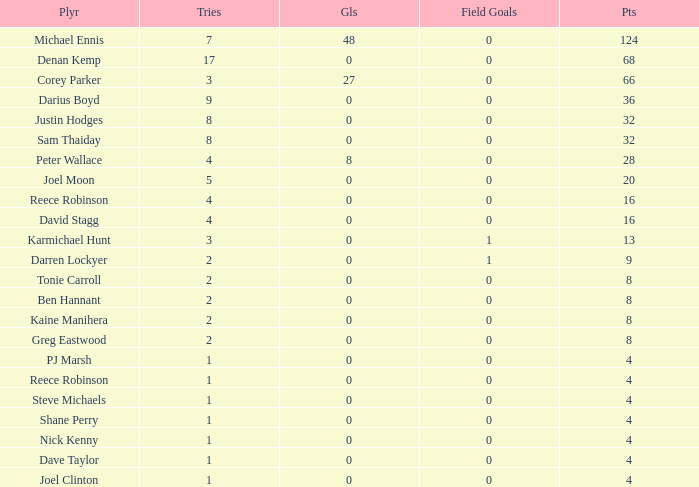Parse the full table. {'header': ['Plyr', 'Tries', 'Gls', 'Field Goals', 'Pts'], 'rows': [['Michael Ennis', '7', '48', '0', '124'], ['Denan Kemp', '17', '0', '0', '68'], ['Corey Parker', '3', '27', '0', '66'], ['Darius Boyd', '9', '0', '0', '36'], ['Justin Hodges', '8', '0', '0', '32'], ['Sam Thaiday', '8', '0', '0', '32'], ['Peter Wallace', '4', '8', '0', '28'], ['Joel Moon', '5', '0', '0', '20'], ['Reece Robinson', '4', '0', '0', '16'], ['David Stagg', '4', '0', '0', '16'], ['Karmichael Hunt', '3', '0', '1', '13'], ['Darren Lockyer', '2', '0', '1', '9'], ['Tonie Carroll', '2', '0', '0', '8'], ['Ben Hannant', '2', '0', '0', '8'], ['Kaine Manihera', '2', '0', '0', '8'], ['Greg Eastwood', '2', '0', '0', '8'], ['PJ Marsh', '1', '0', '0', '4'], ['Reece Robinson', '1', '0', '0', '4'], ['Steve Michaels', '1', '0', '0', '4'], ['Shane Perry', '1', '0', '0', '4'], ['Nick Kenny', '1', '0', '0', '4'], ['Dave Taylor', '1', '0', '0', '4'], ['Joel Clinton', '1', '0', '0', '4']]} How many points did the player with 2 tries and more than 0 field goals have? 9.0. 